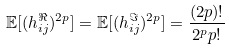<formula> <loc_0><loc_0><loc_500><loc_500>\mathbb { E } [ ( h _ { i j } ^ { \Re } ) ^ { 2 p } ] = \mathbb { E } [ ( h _ { i j } ^ { \Im } ) ^ { 2 p } ] = \frac { ( 2 p ) ! } { 2 ^ { p } p ! }</formula> 